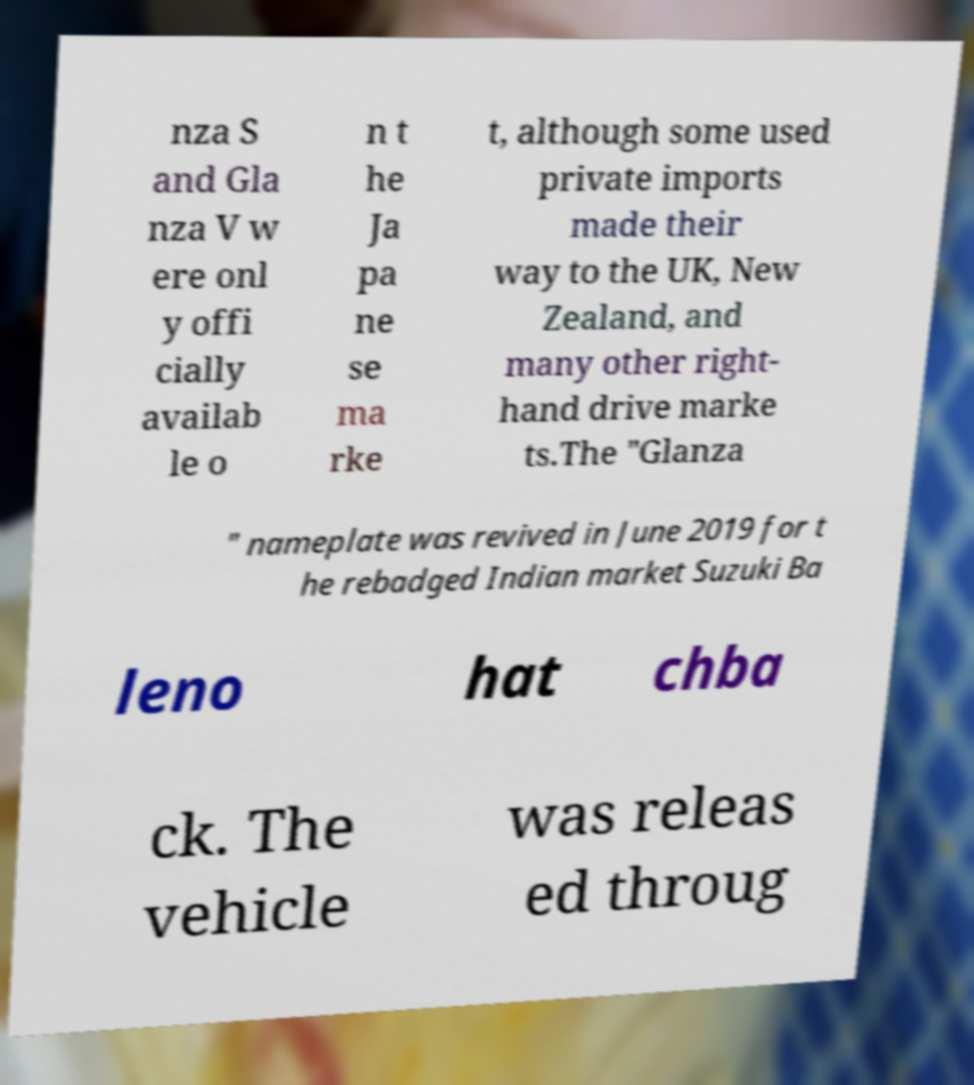Please identify and transcribe the text found in this image. nza S and Gla nza V w ere onl y offi cially availab le o n t he Ja pa ne se ma rke t, although some used private imports made their way to the UK, New Zealand, and many other right- hand drive marke ts.The "Glanza " nameplate was revived in June 2019 for t he rebadged Indian market Suzuki Ba leno hat chba ck. The vehicle was releas ed throug 